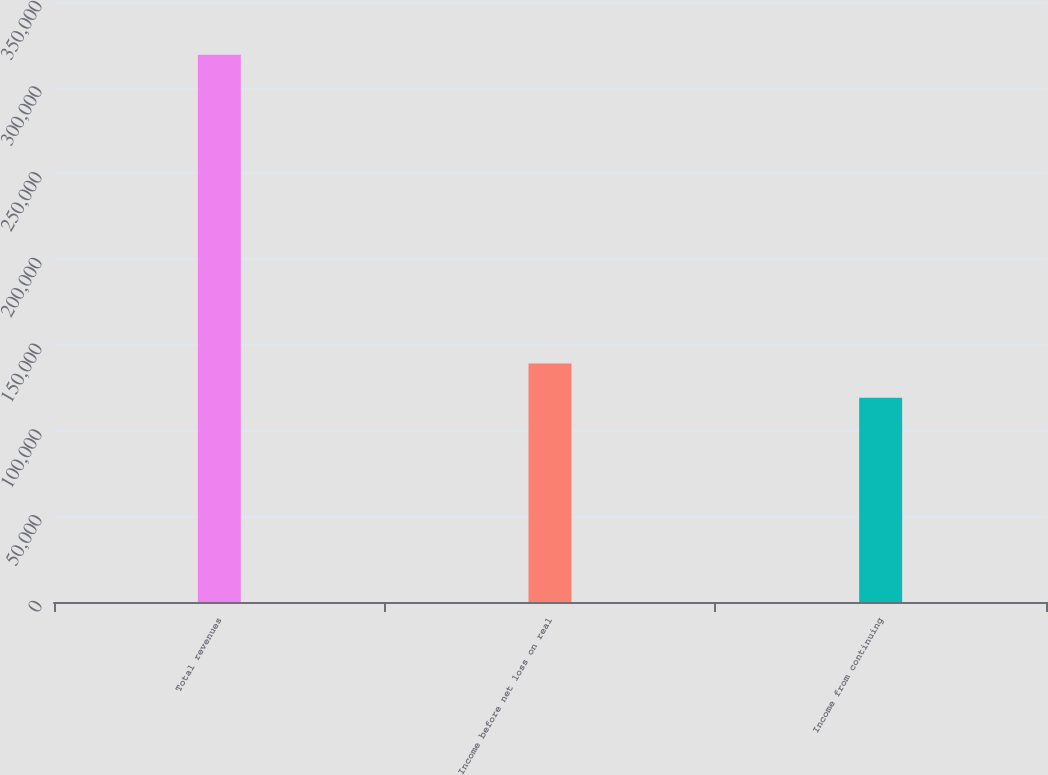Convert chart to OTSL. <chart><loc_0><loc_0><loc_500><loc_500><bar_chart><fcel>Total revenues<fcel>Income before net loss on real<fcel>Income from continuing<nl><fcel>319184<fcel>139128<fcel>119122<nl></chart> 